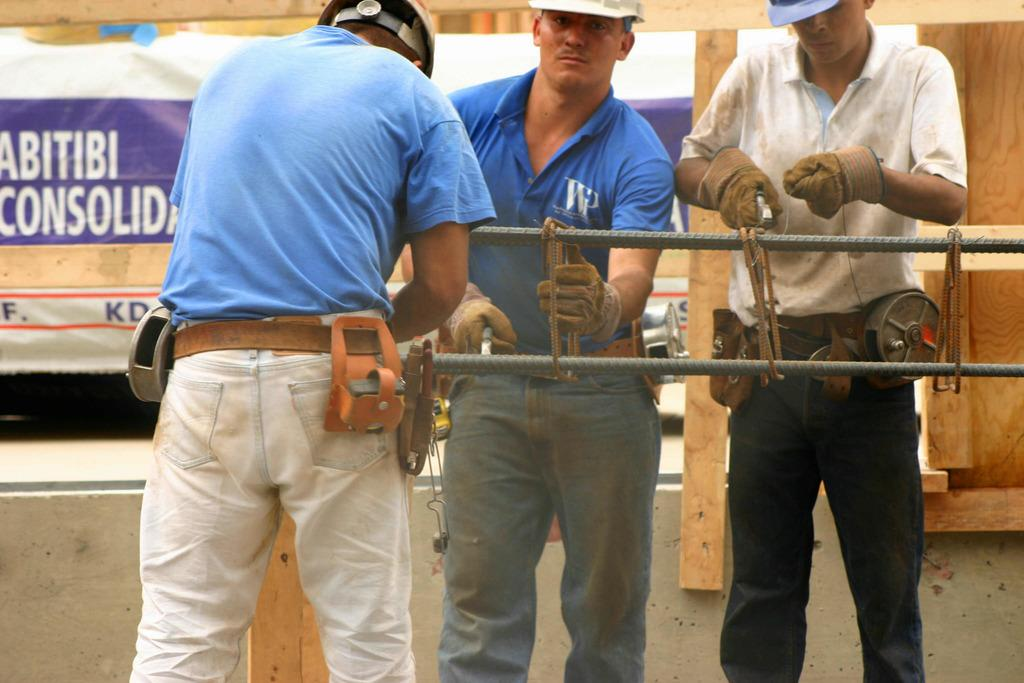How many people are present in the image? There are three people standing in the image. What are the people holding in their hands? The people are holding objects in the image. What can be seen in the background of the image? There are wooden things and a banner with text visible in the background. What type of harmony is being played by the people in the image? There is no indication of music or harmony in the image; the people are simply holding objects. 